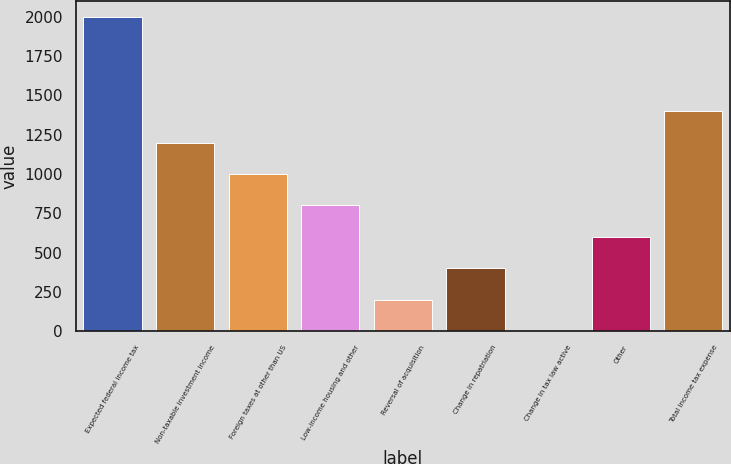<chart> <loc_0><loc_0><loc_500><loc_500><bar_chart><fcel>Expected federal income tax<fcel>Non-taxable investment income<fcel>Foreign taxes at other than US<fcel>Low-income housing and other<fcel>Reversal of acquisition<fcel>Change in repatriation<fcel>Change in tax law active<fcel>Other<fcel>Total income tax expense<nl><fcel>1997<fcel>1198.75<fcel>999.18<fcel>799.61<fcel>200.9<fcel>400.47<fcel>1.33<fcel>600.04<fcel>1398.32<nl></chart> 